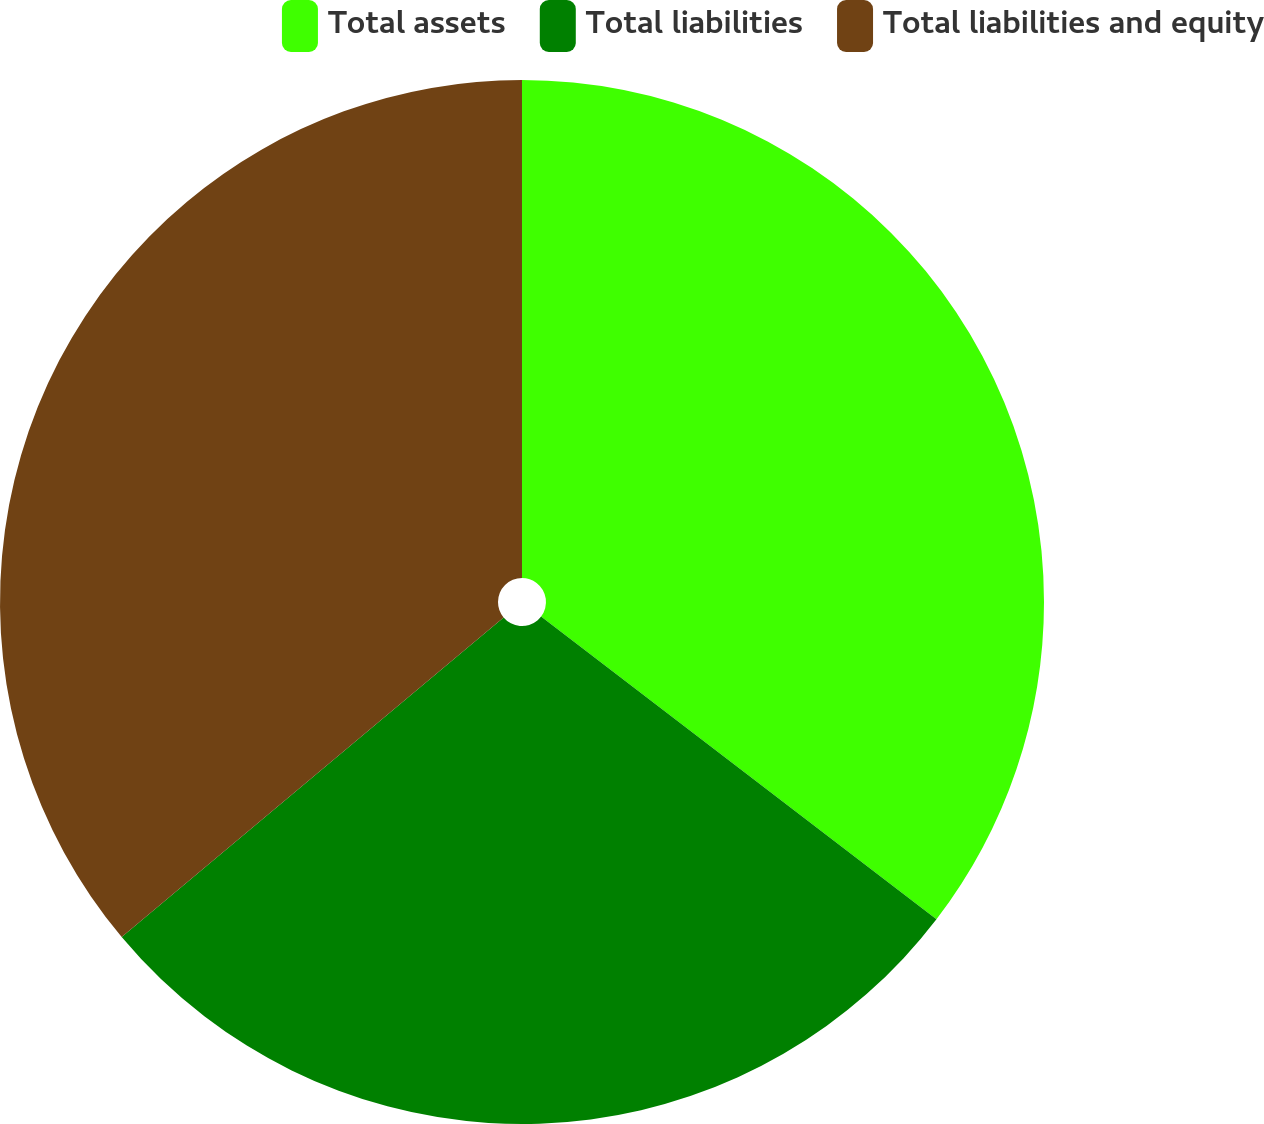<chart> <loc_0><loc_0><loc_500><loc_500><pie_chart><fcel>Total assets<fcel>Total liabilities<fcel>Total liabilities and equity<nl><fcel>35.4%<fcel>28.51%<fcel>36.09%<nl></chart> 